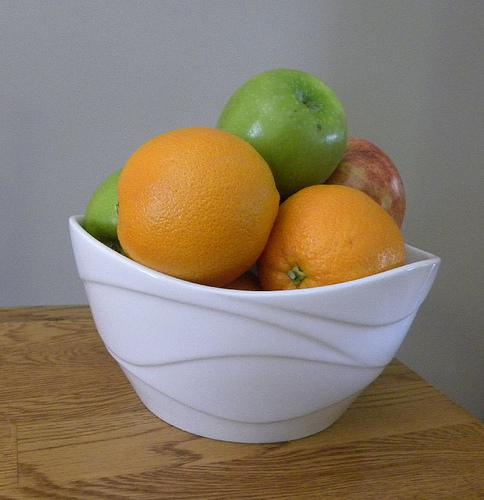Question: when is fruit often eaten?
Choices:
A. For breakfast.
B. In the morning.
C. As a snack.
D. During summer.
Answer with the letter. Answer: C Question: what does an apple a day do?
Choices:
A. Taste good.
B. Keeps the doctor away.
C. Help you be healthy.
D. Attract fruit flies.
Answer with the letter. Answer: B Question: what can be sliced and juiced?
Choices:
A. Apples.
B. Strawberries.
C. Fruit.
D. Oranges.
Answer with the letter. Answer: D Question: what is in the bowl?
Choices:
A. Cereal.
B. Apples.
C. Dog food.
D. Mixed fruit.
Answer with the letter. Answer: D Question: how many fruit are visible?
Choices:
A. 6.
B. 5.
C. 4.
D. 8.
Answer with the letter. Answer: B 